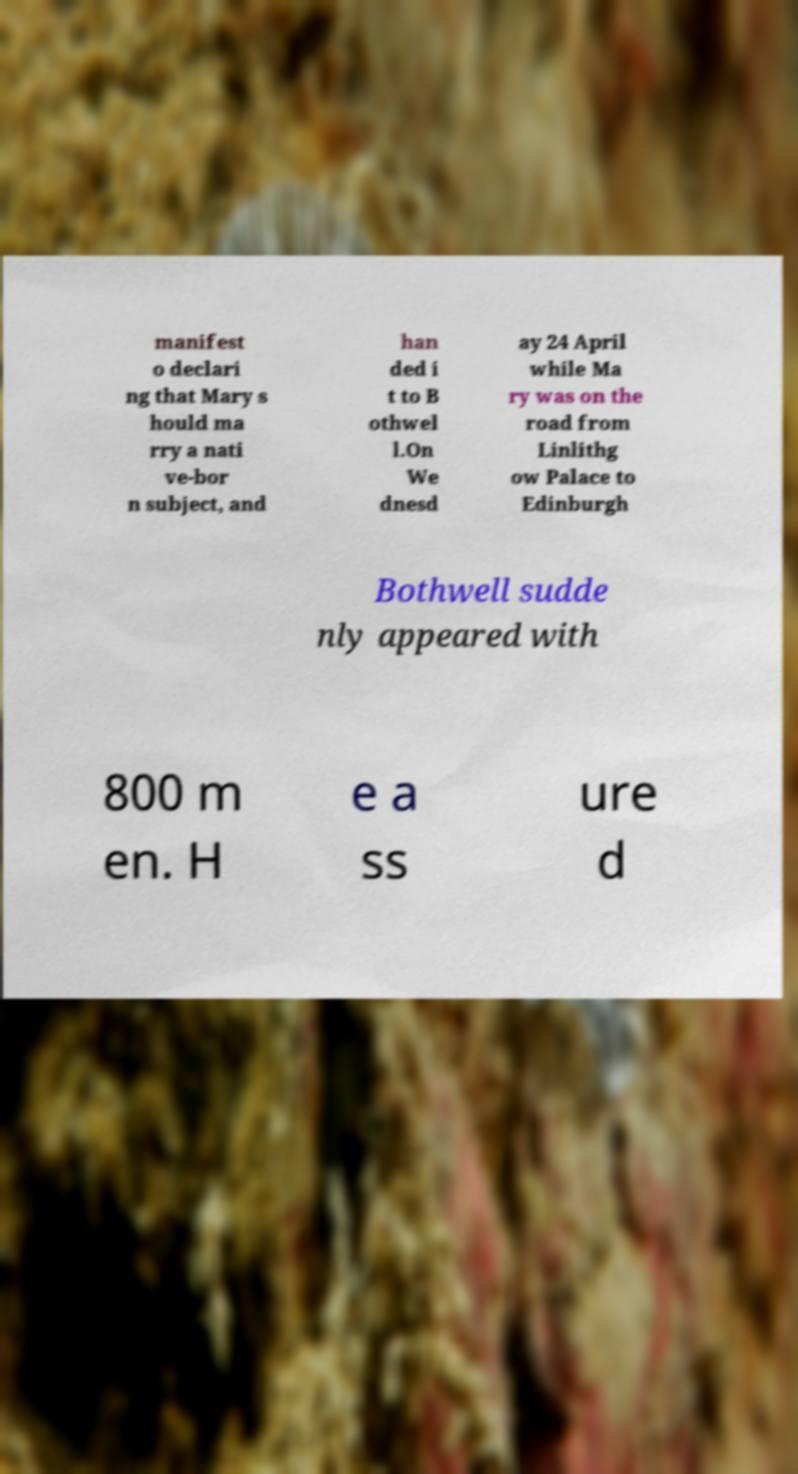What messages or text are displayed in this image? I need them in a readable, typed format. manifest o declari ng that Mary s hould ma rry a nati ve-bor n subject, and han ded i t to B othwel l.On We dnesd ay 24 April while Ma ry was on the road from Linlithg ow Palace to Edinburgh Bothwell sudde nly appeared with 800 m en. H e a ss ure d 